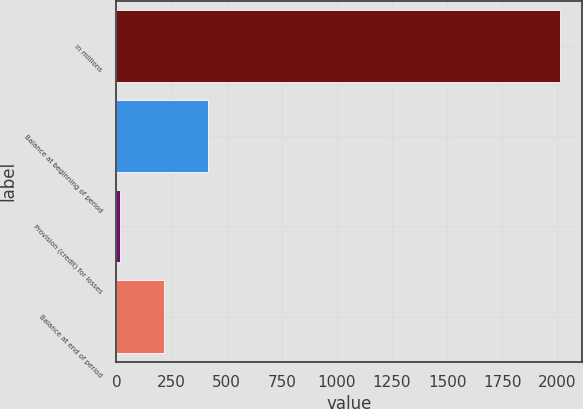<chart> <loc_0><loc_0><loc_500><loc_500><bar_chart><fcel>in millions<fcel>Balance at beginning of period<fcel>Provision (credit) for losses<fcel>Balance at end of period<nl><fcel>2012<fcel>415.2<fcel>16<fcel>215.6<nl></chart> 